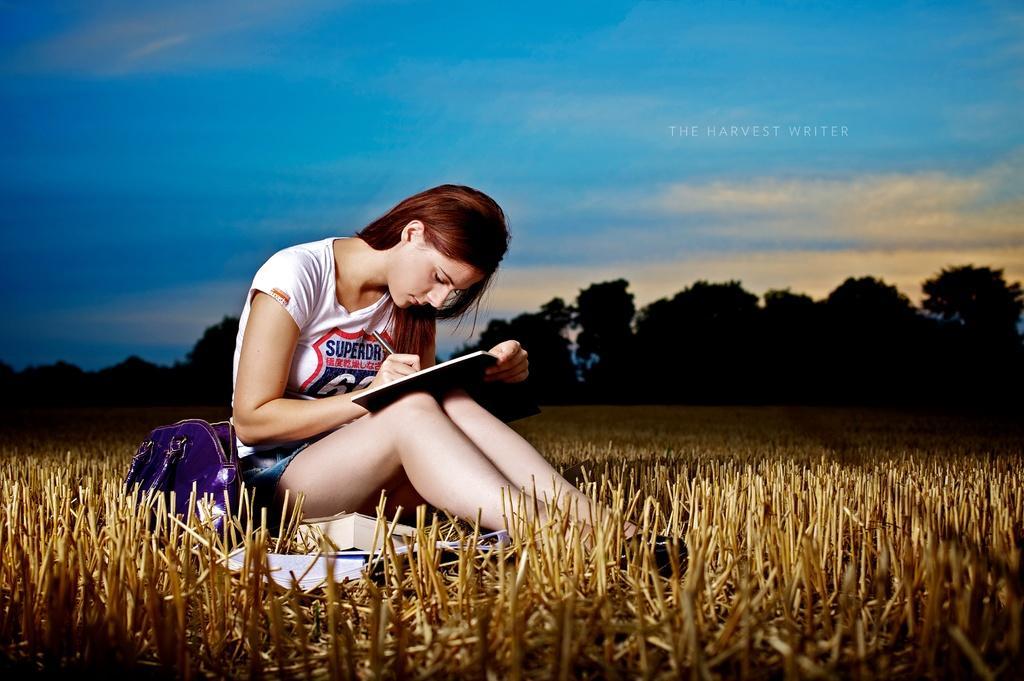Please provide a concise description of this image. In the center of the image we can see one woman is sitting and she is writing something on the book. And we can see one handbag, books and grass. In the background, we can see the sky, clouds and trees. On the right side of the image, we can see some text. 